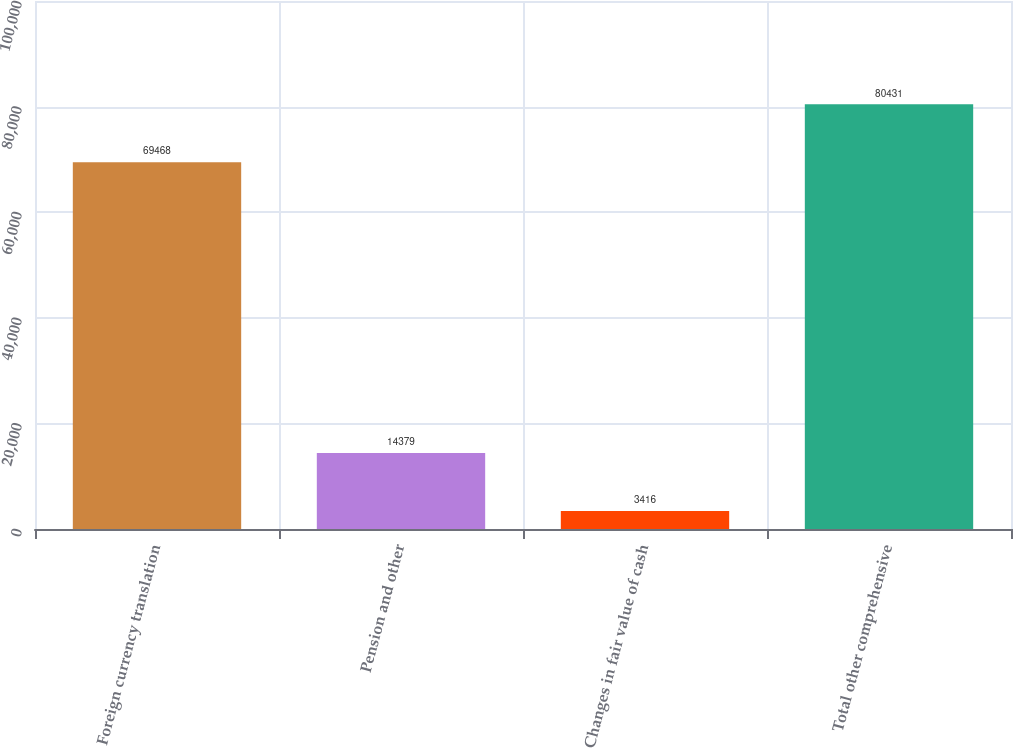Convert chart to OTSL. <chart><loc_0><loc_0><loc_500><loc_500><bar_chart><fcel>Foreign currency translation<fcel>Pension and other<fcel>Changes in fair value of cash<fcel>Total other comprehensive<nl><fcel>69468<fcel>14379<fcel>3416<fcel>80431<nl></chart> 